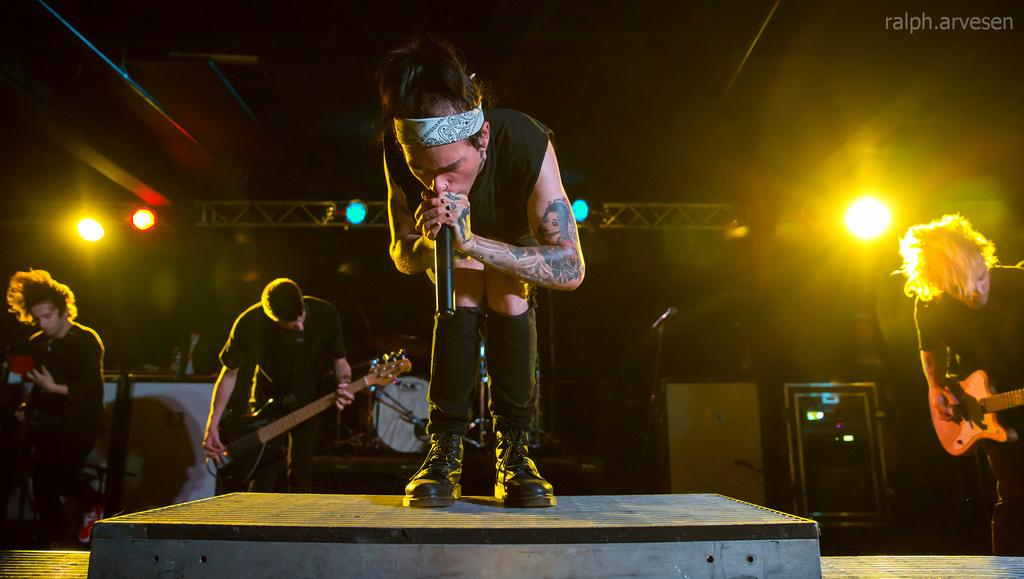How many people are in the image? There are persons in the image. What are the persons doing in the image? The persons are singing. What object is present in the image that is commonly used for amplifying sound? There is a microphone in the image. What musical instrument can be seen in the image? There is a guitar in the image. What type of oatmeal is being served in the image? There is no oatmeal present in the image. Can you tell me how many houses are visible in the image? There are no houses visible in the image. 